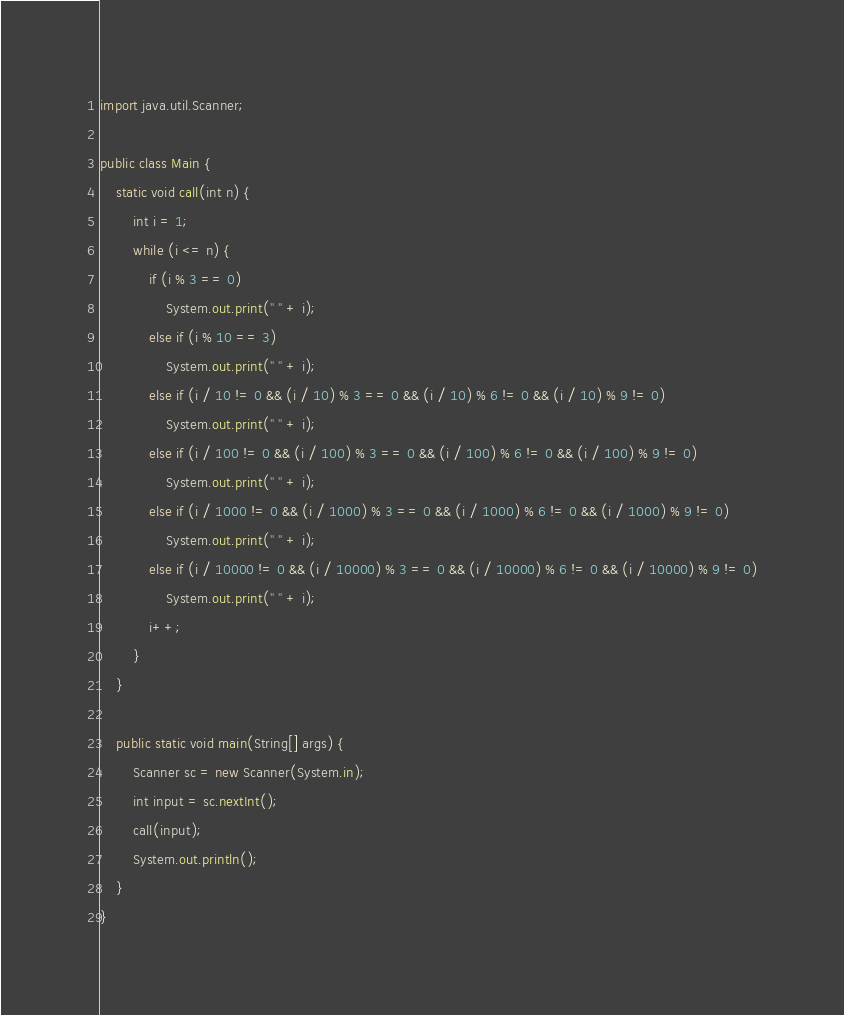<code> <loc_0><loc_0><loc_500><loc_500><_Java_>import java.util.Scanner;

public class Main {
	static void call(int n) {
		int i = 1;
		while (i <= n) {
			if (i % 3 == 0)
				System.out.print(" " + i);
			else if (i % 10 == 3)
				System.out.print(" " + i);
			else if (i / 10 != 0 && (i / 10) % 3 == 0 && (i / 10) % 6 != 0 && (i / 10) % 9 != 0)
				System.out.print(" " + i);
			else if (i / 100 != 0 && (i / 100) % 3 == 0 && (i / 100) % 6 != 0 && (i / 100) % 9 != 0)
				System.out.print(" " + i);
			else if (i / 1000 != 0 && (i / 1000) % 3 == 0 && (i / 1000) % 6 != 0 && (i / 1000) % 9 != 0)
				System.out.print(" " + i);
			else if (i / 10000 != 0 && (i / 10000) % 3 == 0 && (i / 10000) % 6 != 0 && (i / 10000) % 9 != 0)
				System.out.print(" " + i);
			i++;
		}
	}

	public static void main(String[] args) {
		Scanner sc = new Scanner(System.in);
		int input = sc.nextInt();
		call(input);
		System.out.println();
	}
}</code> 